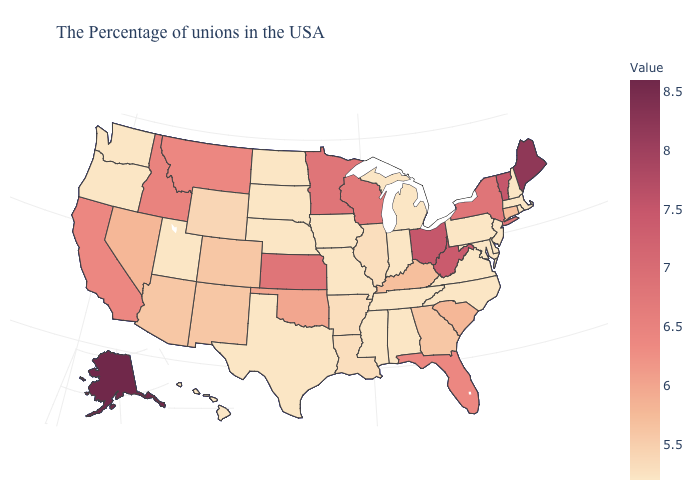Which states have the highest value in the USA?
Answer briefly. Alaska. Does the map have missing data?
Quick response, please. No. Which states have the highest value in the USA?
Quick response, please. Alaska. Which states have the lowest value in the Northeast?
Short answer required. Massachusetts, Rhode Island, New Hampshire, New Jersey, Pennsylvania. Which states have the lowest value in the USA?
Be succinct. Massachusetts, Rhode Island, New Hampshire, New Jersey, Delaware, Maryland, Pennsylvania, Virginia, North Carolina, Michigan, Indiana, Alabama, Tennessee, Mississippi, Missouri, Iowa, Nebraska, Texas, South Dakota, North Dakota, Utah, Washington, Oregon, Hawaii. Among the states that border Missouri , does Iowa have the lowest value?
Write a very short answer. Yes. Does the map have missing data?
Quick response, please. No. 